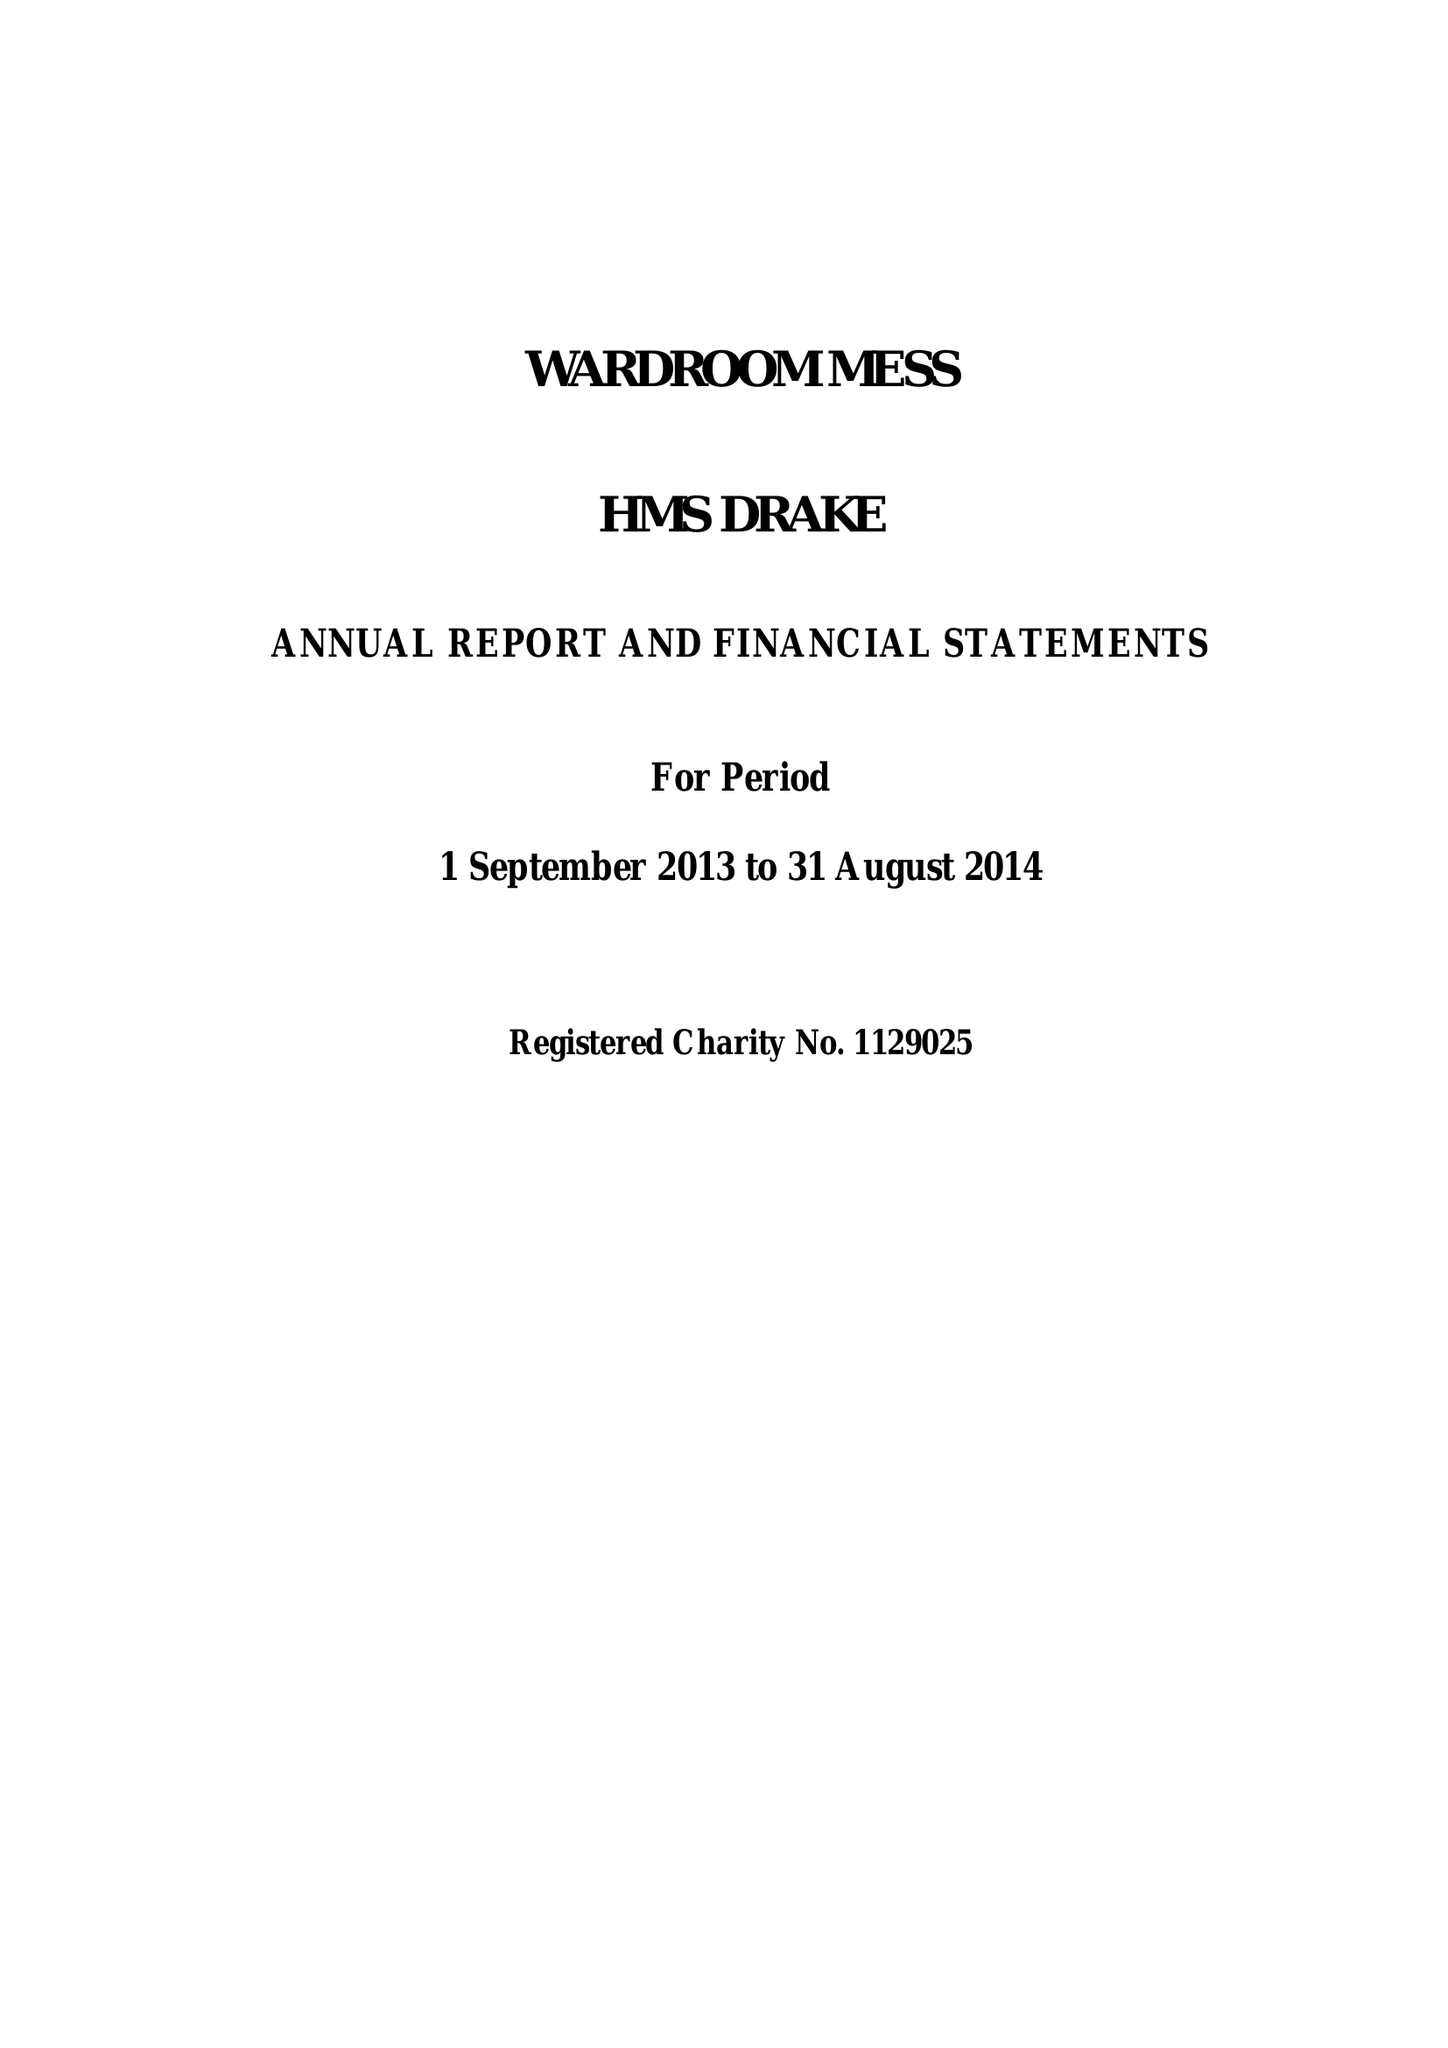What is the value for the spending_annually_in_british_pounds?
Answer the question using a single word or phrase. 184023.37 